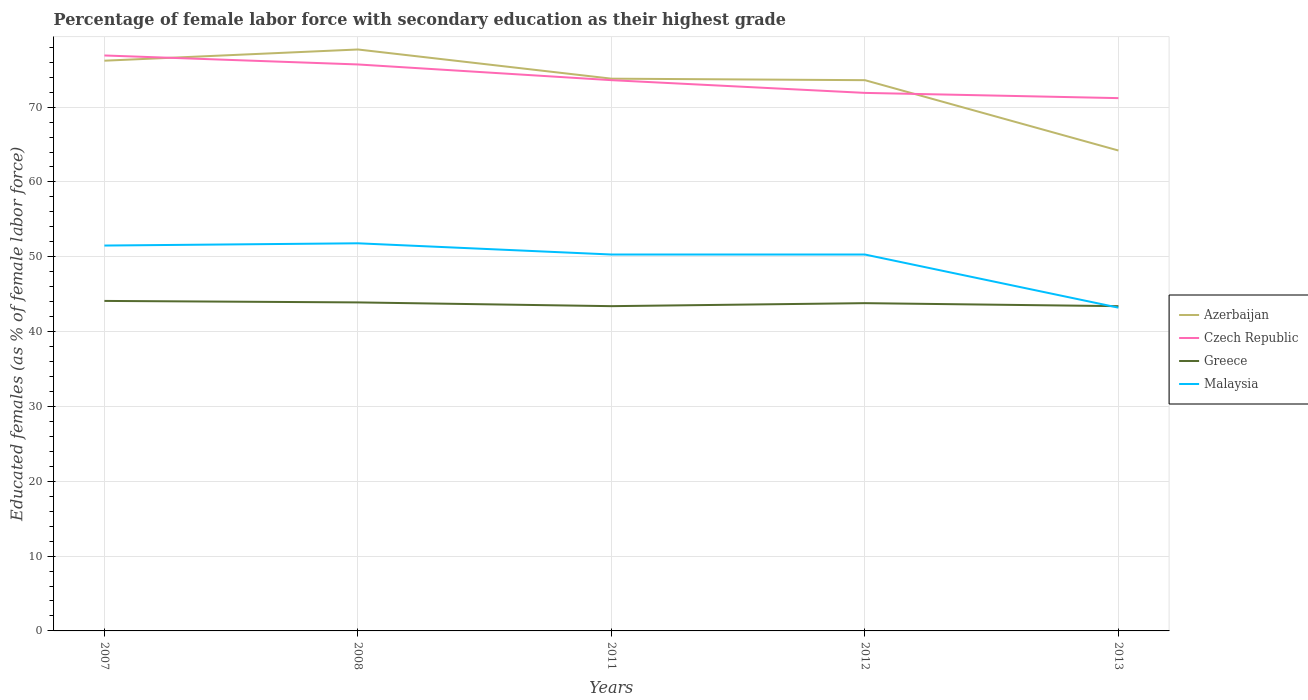Is the number of lines equal to the number of legend labels?
Offer a terse response. Yes. Across all years, what is the maximum percentage of female labor force with secondary education in Greece?
Keep it short and to the point. 43.4. What is the total percentage of female labor force with secondary education in Czech Republic in the graph?
Offer a very short reply. 0.7. What is the difference between the highest and the second highest percentage of female labor force with secondary education in Czech Republic?
Ensure brevity in your answer.  5.7. How many lines are there?
Your answer should be compact. 4. What is the difference between two consecutive major ticks on the Y-axis?
Ensure brevity in your answer.  10. Are the values on the major ticks of Y-axis written in scientific E-notation?
Ensure brevity in your answer.  No. Does the graph contain any zero values?
Your response must be concise. No. Does the graph contain grids?
Your answer should be compact. Yes. How many legend labels are there?
Keep it short and to the point. 4. How are the legend labels stacked?
Ensure brevity in your answer.  Vertical. What is the title of the graph?
Your response must be concise. Percentage of female labor force with secondary education as their highest grade. What is the label or title of the X-axis?
Offer a very short reply. Years. What is the label or title of the Y-axis?
Keep it short and to the point. Educated females (as % of female labor force). What is the Educated females (as % of female labor force) of Azerbaijan in 2007?
Keep it short and to the point. 76.2. What is the Educated females (as % of female labor force) in Czech Republic in 2007?
Your response must be concise. 76.9. What is the Educated females (as % of female labor force) of Greece in 2007?
Give a very brief answer. 44.1. What is the Educated females (as % of female labor force) in Malaysia in 2007?
Provide a succinct answer. 51.5. What is the Educated females (as % of female labor force) of Azerbaijan in 2008?
Ensure brevity in your answer.  77.7. What is the Educated females (as % of female labor force) of Czech Republic in 2008?
Keep it short and to the point. 75.7. What is the Educated females (as % of female labor force) in Greece in 2008?
Your answer should be compact. 43.9. What is the Educated females (as % of female labor force) of Malaysia in 2008?
Ensure brevity in your answer.  51.8. What is the Educated females (as % of female labor force) in Azerbaijan in 2011?
Provide a succinct answer. 73.8. What is the Educated females (as % of female labor force) of Czech Republic in 2011?
Your response must be concise. 73.6. What is the Educated females (as % of female labor force) of Greece in 2011?
Offer a very short reply. 43.4. What is the Educated females (as % of female labor force) of Malaysia in 2011?
Offer a terse response. 50.3. What is the Educated females (as % of female labor force) in Azerbaijan in 2012?
Provide a succinct answer. 73.6. What is the Educated females (as % of female labor force) in Czech Republic in 2012?
Ensure brevity in your answer.  71.9. What is the Educated females (as % of female labor force) in Greece in 2012?
Offer a terse response. 43.8. What is the Educated females (as % of female labor force) of Malaysia in 2012?
Ensure brevity in your answer.  50.3. What is the Educated females (as % of female labor force) in Azerbaijan in 2013?
Give a very brief answer. 64.2. What is the Educated females (as % of female labor force) of Czech Republic in 2013?
Offer a very short reply. 71.2. What is the Educated females (as % of female labor force) in Greece in 2013?
Ensure brevity in your answer.  43.4. What is the Educated females (as % of female labor force) in Malaysia in 2013?
Your answer should be compact. 43.2. Across all years, what is the maximum Educated females (as % of female labor force) of Azerbaijan?
Keep it short and to the point. 77.7. Across all years, what is the maximum Educated females (as % of female labor force) in Czech Republic?
Offer a terse response. 76.9. Across all years, what is the maximum Educated females (as % of female labor force) in Greece?
Provide a short and direct response. 44.1. Across all years, what is the maximum Educated females (as % of female labor force) of Malaysia?
Offer a very short reply. 51.8. Across all years, what is the minimum Educated females (as % of female labor force) in Azerbaijan?
Your answer should be compact. 64.2. Across all years, what is the minimum Educated females (as % of female labor force) in Czech Republic?
Provide a succinct answer. 71.2. Across all years, what is the minimum Educated females (as % of female labor force) in Greece?
Your response must be concise. 43.4. Across all years, what is the minimum Educated females (as % of female labor force) of Malaysia?
Provide a succinct answer. 43.2. What is the total Educated females (as % of female labor force) of Azerbaijan in the graph?
Your answer should be compact. 365.5. What is the total Educated females (as % of female labor force) in Czech Republic in the graph?
Provide a short and direct response. 369.3. What is the total Educated females (as % of female labor force) of Greece in the graph?
Give a very brief answer. 218.6. What is the total Educated females (as % of female labor force) of Malaysia in the graph?
Provide a succinct answer. 247.1. What is the difference between the Educated females (as % of female labor force) in Greece in 2007 and that in 2008?
Keep it short and to the point. 0.2. What is the difference between the Educated females (as % of female labor force) in Czech Republic in 2007 and that in 2011?
Your answer should be compact. 3.3. What is the difference between the Educated females (as % of female labor force) in Greece in 2007 and that in 2011?
Your answer should be compact. 0.7. What is the difference between the Educated females (as % of female labor force) in Malaysia in 2007 and that in 2011?
Keep it short and to the point. 1.2. What is the difference between the Educated females (as % of female labor force) in Azerbaijan in 2007 and that in 2012?
Offer a terse response. 2.6. What is the difference between the Educated females (as % of female labor force) of Czech Republic in 2007 and that in 2012?
Give a very brief answer. 5. What is the difference between the Educated females (as % of female labor force) in Greece in 2007 and that in 2012?
Make the answer very short. 0.3. What is the difference between the Educated females (as % of female labor force) in Azerbaijan in 2007 and that in 2013?
Your answer should be compact. 12. What is the difference between the Educated females (as % of female labor force) in Czech Republic in 2008 and that in 2011?
Provide a succinct answer. 2.1. What is the difference between the Educated females (as % of female labor force) in Czech Republic in 2008 and that in 2012?
Your answer should be compact. 3.8. What is the difference between the Educated females (as % of female labor force) in Malaysia in 2008 and that in 2013?
Make the answer very short. 8.6. What is the difference between the Educated females (as % of female labor force) in Czech Republic in 2011 and that in 2012?
Provide a succinct answer. 1.7. What is the difference between the Educated females (as % of female labor force) in Malaysia in 2011 and that in 2012?
Offer a very short reply. 0. What is the difference between the Educated females (as % of female labor force) in Czech Republic in 2011 and that in 2013?
Ensure brevity in your answer.  2.4. What is the difference between the Educated females (as % of female labor force) in Malaysia in 2011 and that in 2013?
Provide a succinct answer. 7.1. What is the difference between the Educated females (as % of female labor force) in Czech Republic in 2012 and that in 2013?
Your answer should be very brief. 0.7. What is the difference between the Educated females (as % of female labor force) in Azerbaijan in 2007 and the Educated females (as % of female labor force) in Czech Republic in 2008?
Your response must be concise. 0.5. What is the difference between the Educated females (as % of female labor force) of Azerbaijan in 2007 and the Educated females (as % of female labor force) of Greece in 2008?
Keep it short and to the point. 32.3. What is the difference between the Educated females (as % of female labor force) of Azerbaijan in 2007 and the Educated females (as % of female labor force) of Malaysia in 2008?
Ensure brevity in your answer.  24.4. What is the difference between the Educated females (as % of female labor force) of Czech Republic in 2007 and the Educated females (as % of female labor force) of Malaysia in 2008?
Give a very brief answer. 25.1. What is the difference between the Educated females (as % of female labor force) in Greece in 2007 and the Educated females (as % of female labor force) in Malaysia in 2008?
Give a very brief answer. -7.7. What is the difference between the Educated females (as % of female labor force) of Azerbaijan in 2007 and the Educated females (as % of female labor force) of Greece in 2011?
Your response must be concise. 32.8. What is the difference between the Educated females (as % of female labor force) in Azerbaijan in 2007 and the Educated females (as % of female labor force) in Malaysia in 2011?
Your answer should be compact. 25.9. What is the difference between the Educated females (as % of female labor force) in Czech Republic in 2007 and the Educated females (as % of female labor force) in Greece in 2011?
Offer a very short reply. 33.5. What is the difference between the Educated females (as % of female labor force) in Czech Republic in 2007 and the Educated females (as % of female labor force) in Malaysia in 2011?
Your answer should be very brief. 26.6. What is the difference between the Educated females (as % of female labor force) of Azerbaijan in 2007 and the Educated females (as % of female labor force) of Greece in 2012?
Keep it short and to the point. 32.4. What is the difference between the Educated females (as % of female labor force) in Azerbaijan in 2007 and the Educated females (as % of female labor force) in Malaysia in 2012?
Offer a terse response. 25.9. What is the difference between the Educated females (as % of female labor force) of Czech Republic in 2007 and the Educated females (as % of female labor force) of Greece in 2012?
Offer a very short reply. 33.1. What is the difference between the Educated females (as % of female labor force) in Czech Republic in 2007 and the Educated females (as % of female labor force) in Malaysia in 2012?
Keep it short and to the point. 26.6. What is the difference between the Educated females (as % of female labor force) of Greece in 2007 and the Educated females (as % of female labor force) of Malaysia in 2012?
Your response must be concise. -6.2. What is the difference between the Educated females (as % of female labor force) in Azerbaijan in 2007 and the Educated females (as % of female labor force) in Czech Republic in 2013?
Your answer should be compact. 5. What is the difference between the Educated females (as % of female labor force) in Azerbaijan in 2007 and the Educated females (as % of female labor force) in Greece in 2013?
Make the answer very short. 32.8. What is the difference between the Educated females (as % of female labor force) of Azerbaijan in 2007 and the Educated females (as % of female labor force) of Malaysia in 2013?
Make the answer very short. 33. What is the difference between the Educated females (as % of female labor force) of Czech Republic in 2007 and the Educated females (as % of female labor force) of Greece in 2013?
Ensure brevity in your answer.  33.5. What is the difference between the Educated females (as % of female labor force) in Czech Republic in 2007 and the Educated females (as % of female labor force) in Malaysia in 2013?
Ensure brevity in your answer.  33.7. What is the difference between the Educated females (as % of female labor force) in Azerbaijan in 2008 and the Educated females (as % of female labor force) in Czech Republic in 2011?
Your answer should be compact. 4.1. What is the difference between the Educated females (as % of female labor force) of Azerbaijan in 2008 and the Educated females (as % of female labor force) of Greece in 2011?
Your answer should be compact. 34.3. What is the difference between the Educated females (as % of female labor force) of Azerbaijan in 2008 and the Educated females (as % of female labor force) of Malaysia in 2011?
Provide a short and direct response. 27.4. What is the difference between the Educated females (as % of female labor force) in Czech Republic in 2008 and the Educated females (as % of female labor force) in Greece in 2011?
Your response must be concise. 32.3. What is the difference between the Educated females (as % of female labor force) in Czech Republic in 2008 and the Educated females (as % of female labor force) in Malaysia in 2011?
Make the answer very short. 25.4. What is the difference between the Educated females (as % of female labor force) of Greece in 2008 and the Educated females (as % of female labor force) of Malaysia in 2011?
Make the answer very short. -6.4. What is the difference between the Educated females (as % of female labor force) of Azerbaijan in 2008 and the Educated females (as % of female labor force) of Greece in 2012?
Give a very brief answer. 33.9. What is the difference between the Educated females (as % of female labor force) in Azerbaijan in 2008 and the Educated females (as % of female labor force) in Malaysia in 2012?
Offer a very short reply. 27.4. What is the difference between the Educated females (as % of female labor force) of Czech Republic in 2008 and the Educated females (as % of female labor force) of Greece in 2012?
Your answer should be compact. 31.9. What is the difference between the Educated females (as % of female labor force) of Czech Republic in 2008 and the Educated females (as % of female labor force) of Malaysia in 2012?
Keep it short and to the point. 25.4. What is the difference between the Educated females (as % of female labor force) in Greece in 2008 and the Educated females (as % of female labor force) in Malaysia in 2012?
Your answer should be compact. -6.4. What is the difference between the Educated females (as % of female labor force) of Azerbaijan in 2008 and the Educated females (as % of female labor force) of Czech Republic in 2013?
Offer a terse response. 6.5. What is the difference between the Educated females (as % of female labor force) of Azerbaijan in 2008 and the Educated females (as % of female labor force) of Greece in 2013?
Give a very brief answer. 34.3. What is the difference between the Educated females (as % of female labor force) in Azerbaijan in 2008 and the Educated females (as % of female labor force) in Malaysia in 2013?
Provide a short and direct response. 34.5. What is the difference between the Educated females (as % of female labor force) in Czech Republic in 2008 and the Educated females (as % of female labor force) in Greece in 2013?
Your answer should be compact. 32.3. What is the difference between the Educated females (as % of female labor force) of Czech Republic in 2008 and the Educated females (as % of female labor force) of Malaysia in 2013?
Provide a succinct answer. 32.5. What is the difference between the Educated females (as % of female labor force) of Greece in 2008 and the Educated females (as % of female labor force) of Malaysia in 2013?
Make the answer very short. 0.7. What is the difference between the Educated females (as % of female labor force) in Azerbaijan in 2011 and the Educated females (as % of female labor force) in Malaysia in 2012?
Your answer should be compact. 23.5. What is the difference between the Educated females (as % of female labor force) of Czech Republic in 2011 and the Educated females (as % of female labor force) of Greece in 2012?
Offer a very short reply. 29.8. What is the difference between the Educated females (as % of female labor force) of Czech Republic in 2011 and the Educated females (as % of female labor force) of Malaysia in 2012?
Ensure brevity in your answer.  23.3. What is the difference between the Educated females (as % of female labor force) in Greece in 2011 and the Educated females (as % of female labor force) in Malaysia in 2012?
Your answer should be very brief. -6.9. What is the difference between the Educated females (as % of female labor force) of Azerbaijan in 2011 and the Educated females (as % of female labor force) of Czech Republic in 2013?
Your answer should be very brief. 2.6. What is the difference between the Educated females (as % of female labor force) in Azerbaijan in 2011 and the Educated females (as % of female labor force) in Greece in 2013?
Make the answer very short. 30.4. What is the difference between the Educated females (as % of female labor force) of Azerbaijan in 2011 and the Educated females (as % of female labor force) of Malaysia in 2013?
Keep it short and to the point. 30.6. What is the difference between the Educated females (as % of female labor force) in Czech Republic in 2011 and the Educated females (as % of female labor force) in Greece in 2013?
Make the answer very short. 30.2. What is the difference between the Educated females (as % of female labor force) in Czech Republic in 2011 and the Educated females (as % of female labor force) in Malaysia in 2013?
Your answer should be compact. 30.4. What is the difference between the Educated females (as % of female labor force) in Azerbaijan in 2012 and the Educated females (as % of female labor force) in Greece in 2013?
Offer a very short reply. 30.2. What is the difference between the Educated females (as % of female labor force) of Azerbaijan in 2012 and the Educated females (as % of female labor force) of Malaysia in 2013?
Make the answer very short. 30.4. What is the difference between the Educated females (as % of female labor force) in Czech Republic in 2012 and the Educated females (as % of female labor force) in Malaysia in 2013?
Provide a short and direct response. 28.7. What is the average Educated females (as % of female labor force) of Azerbaijan per year?
Provide a short and direct response. 73.1. What is the average Educated females (as % of female labor force) in Czech Republic per year?
Ensure brevity in your answer.  73.86. What is the average Educated females (as % of female labor force) of Greece per year?
Offer a terse response. 43.72. What is the average Educated females (as % of female labor force) in Malaysia per year?
Make the answer very short. 49.42. In the year 2007, what is the difference between the Educated females (as % of female labor force) of Azerbaijan and Educated females (as % of female labor force) of Greece?
Keep it short and to the point. 32.1. In the year 2007, what is the difference between the Educated females (as % of female labor force) of Azerbaijan and Educated females (as % of female labor force) of Malaysia?
Keep it short and to the point. 24.7. In the year 2007, what is the difference between the Educated females (as % of female labor force) in Czech Republic and Educated females (as % of female labor force) in Greece?
Your answer should be very brief. 32.8. In the year 2007, what is the difference between the Educated females (as % of female labor force) in Czech Republic and Educated females (as % of female labor force) in Malaysia?
Make the answer very short. 25.4. In the year 2008, what is the difference between the Educated females (as % of female labor force) of Azerbaijan and Educated females (as % of female labor force) of Czech Republic?
Offer a very short reply. 2. In the year 2008, what is the difference between the Educated females (as % of female labor force) in Azerbaijan and Educated females (as % of female labor force) in Greece?
Your answer should be compact. 33.8. In the year 2008, what is the difference between the Educated females (as % of female labor force) in Azerbaijan and Educated females (as % of female labor force) in Malaysia?
Make the answer very short. 25.9. In the year 2008, what is the difference between the Educated females (as % of female labor force) in Czech Republic and Educated females (as % of female labor force) in Greece?
Offer a terse response. 31.8. In the year 2008, what is the difference between the Educated females (as % of female labor force) in Czech Republic and Educated females (as % of female labor force) in Malaysia?
Ensure brevity in your answer.  23.9. In the year 2011, what is the difference between the Educated females (as % of female labor force) in Azerbaijan and Educated females (as % of female labor force) in Czech Republic?
Give a very brief answer. 0.2. In the year 2011, what is the difference between the Educated females (as % of female labor force) in Azerbaijan and Educated females (as % of female labor force) in Greece?
Offer a very short reply. 30.4. In the year 2011, what is the difference between the Educated females (as % of female labor force) in Azerbaijan and Educated females (as % of female labor force) in Malaysia?
Offer a terse response. 23.5. In the year 2011, what is the difference between the Educated females (as % of female labor force) in Czech Republic and Educated females (as % of female labor force) in Greece?
Offer a very short reply. 30.2. In the year 2011, what is the difference between the Educated females (as % of female labor force) of Czech Republic and Educated females (as % of female labor force) of Malaysia?
Keep it short and to the point. 23.3. In the year 2011, what is the difference between the Educated females (as % of female labor force) of Greece and Educated females (as % of female labor force) of Malaysia?
Your response must be concise. -6.9. In the year 2012, what is the difference between the Educated females (as % of female labor force) in Azerbaijan and Educated females (as % of female labor force) in Czech Republic?
Make the answer very short. 1.7. In the year 2012, what is the difference between the Educated females (as % of female labor force) of Azerbaijan and Educated females (as % of female labor force) of Greece?
Your answer should be compact. 29.8. In the year 2012, what is the difference between the Educated females (as % of female labor force) of Azerbaijan and Educated females (as % of female labor force) of Malaysia?
Keep it short and to the point. 23.3. In the year 2012, what is the difference between the Educated females (as % of female labor force) in Czech Republic and Educated females (as % of female labor force) in Greece?
Provide a succinct answer. 28.1. In the year 2012, what is the difference between the Educated females (as % of female labor force) of Czech Republic and Educated females (as % of female labor force) of Malaysia?
Give a very brief answer. 21.6. In the year 2012, what is the difference between the Educated females (as % of female labor force) in Greece and Educated females (as % of female labor force) in Malaysia?
Give a very brief answer. -6.5. In the year 2013, what is the difference between the Educated females (as % of female labor force) in Azerbaijan and Educated females (as % of female labor force) in Czech Republic?
Provide a short and direct response. -7. In the year 2013, what is the difference between the Educated females (as % of female labor force) in Azerbaijan and Educated females (as % of female labor force) in Greece?
Provide a succinct answer. 20.8. In the year 2013, what is the difference between the Educated females (as % of female labor force) of Czech Republic and Educated females (as % of female labor force) of Greece?
Provide a succinct answer. 27.8. In the year 2013, what is the difference between the Educated females (as % of female labor force) of Czech Republic and Educated females (as % of female labor force) of Malaysia?
Keep it short and to the point. 28. In the year 2013, what is the difference between the Educated females (as % of female labor force) of Greece and Educated females (as % of female labor force) of Malaysia?
Provide a succinct answer. 0.2. What is the ratio of the Educated females (as % of female labor force) of Azerbaijan in 2007 to that in 2008?
Provide a succinct answer. 0.98. What is the ratio of the Educated females (as % of female labor force) in Czech Republic in 2007 to that in 2008?
Give a very brief answer. 1.02. What is the ratio of the Educated females (as % of female labor force) in Greece in 2007 to that in 2008?
Ensure brevity in your answer.  1. What is the ratio of the Educated females (as % of female labor force) of Malaysia in 2007 to that in 2008?
Your answer should be compact. 0.99. What is the ratio of the Educated females (as % of female labor force) in Azerbaijan in 2007 to that in 2011?
Make the answer very short. 1.03. What is the ratio of the Educated females (as % of female labor force) in Czech Republic in 2007 to that in 2011?
Ensure brevity in your answer.  1.04. What is the ratio of the Educated females (as % of female labor force) of Greece in 2007 to that in 2011?
Make the answer very short. 1.02. What is the ratio of the Educated females (as % of female labor force) in Malaysia in 2007 to that in 2011?
Give a very brief answer. 1.02. What is the ratio of the Educated females (as % of female labor force) in Azerbaijan in 2007 to that in 2012?
Provide a short and direct response. 1.04. What is the ratio of the Educated females (as % of female labor force) in Czech Republic in 2007 to that in 2012?
Offer a terse response. 1.07. What is the ratio of the Educated females (as % of female labor force) in Greece in 2007 to that in 2012?
Ensure brevity in your answer.  1.01. What is the ratio of the Educated females (as % of female labor force) of Malaysia in 2007 to that in 2012?
Offer a very short reply. 1.02. What is the ratio of the Educated females (as % of female labor force) in Azerbaijan in 2007 to that in 2013?
Give a very brief answer. 1.19. What is the ratio of the Educated females (as % of female labor force) in Czech Republic in 2007 to that in 2013?
Ensure brevity in your answer.  1.08. What is the ratio of the Educated females (as % of female labor force) of Greece in 2007 to that in 2013?
Offer a terse response. 1.02. What is the ratio of the Educated females (as % of female labor force) in Malaysia in 2007 to that in 2013?
Make the answer very short. 1.19. What is the ratio of the Educated females (as % of female labor force) in Azerbaijan in 2008 to that in 2011?
Your response must be concise. 1.05. What is the ratio of the Educated females (as % of female labor force) in Czech Republic in 2008 to that in 2011?
Offer a terse response. 1.03. What is the ratio of the Educated females (as % of female labor force) of Greece in 2008 to that in 2011?
Provide a succinct answer. 1.01. What is the ratio of the Educated females (as % of female labor force) in Malaysia in 2008 to that in 2011?
Provide a succinct answer. 1.03. What is the ratio of the Educated females (as % of female labor force) of Azerbaijan in 2008 to that in 2012?
Keep it short and to the point. 1.06. What is the ratio of the Educated females (as % of female labor force) in Czech Republic in 2008 to that in 2012?
Provide a short and direct response. 1.05. What is the ratio of the Educated females (as % of female labor force) of Malaysia in 2008 to that in 2012?
Ensure brevity in your answer.  1.03. What is the ratio of the Educated females (as % of female labor force) in Azerbaijan in 2008 to that in 2013?
Your answer should be very brief. 1.21. What is the ratio of the Educated females (as % of female labor force) of Czech Republic in 2008 to that in 2013?
Offer a terse response. 1.06. What is the ratio of the Educated females (as % of female labor force) of Greece in 2008 to that in 2013?
Give a very brief answer. 1.01. What is the ratio of the Educated females (as % of female labor force) in Malaysia in 2008 to that in 2013?
Provide a short and direct response. 1.2. What is the ratio of the Educated females (as % of female labor force) of Azerbaijan in 2011 to that in 2012?
Provide a succinct answer. 1. What is the ratio of the Educated females (as % of female labor force) in Czech Republic in 2011 to that in 2012?
Provide a short and direct response. 1.02. What is the ratio of the Educated females (as % of female labor force) of Greece in 2011 to that in 2012?
Your answer should be compact. 0.99. What is the ratio of the Educated females (as % of female labor force) of Azerbaijan in 2011 to that in 2013?
Offer a very short reply. 1.15. What is the ratio of the Educated females (as % of female labor force) in Czech Republic in 2011 to that in 2013?
Your response must be concise. 1.03. What is the ratio of the Educated females (as % of female labor force) of Malaysia in 2011 to that in 2013?
Give a very brief answer. 1.16. What is the ratio of the Educated females (as % of female labor force) in Azerbaijan in 2012 to that in 2013?
Offer a terse response. 1.15. What is the ratio of the Educated females (as % of female labor force) of Czech Republic in 2012 to that in 2013?
Provide a short and direct response. 1.01. What is the ratio of the Educated females (as % of female labor force) in Greece in 2012 to that in 2013?
Keep it short and to the point. 1.01. What is the ratio of the Educated females (as % of female labor force) in Malaysia in 2012 to that in 2013?
Your answer should be compact. 1.16. What is the difference between the highest and the second highest Educated females (as % of female labor force) in Azerbaijan?
Provide a short and direct response. 1.5. What is the difference between the highest and the second highest Educated females (as % of female labor force) in Czech Republic?
Provide a succinct answer. 1.2. What is the difference between the highest and the second highest Educated females (as % of female labor force) in Malaysia?
Provide a short and direct response. 0.3. What is the difference between the highest and the lowest Educated females (as % of female labor force) of Malaysia?
Your answer should be very brief. 8.6. 